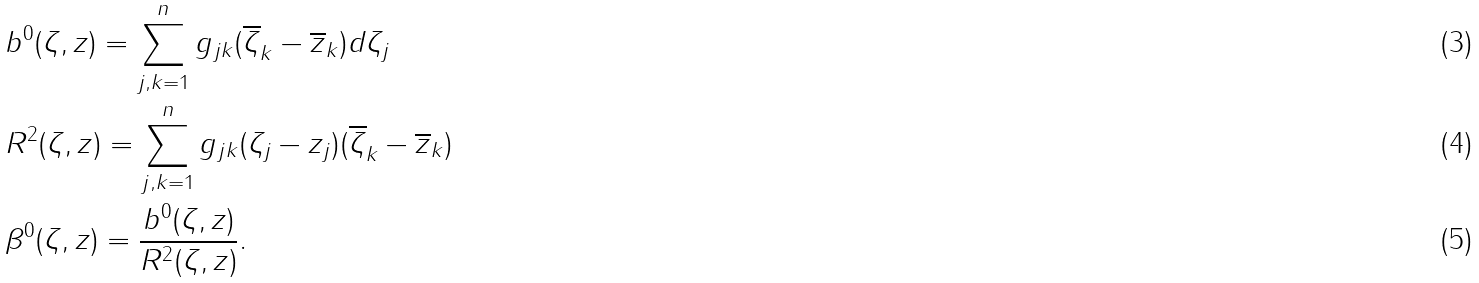Convert formula to latex. <formula><loc_0><loc_0><loc_500><loc_500>& b ^ { 0 } ( \zeta , z ) = \sum _ { j , k = 1 } ^ { n } g _ { j k } ( \overline { \zeta } _ { k } - \overline { z } _ { k } ) d \zeta _ { j } \\ & R ^ { 2 } ( \zeta , z ) = \sum _ { j , k = 1 } ^ { n } g _ { j k } ( \zeta _ { j } - z _ { j } ) ( \overline { \zeta } _ { k } - \overline { z } _ { k } ) \\ & \beta ^ { 0 } ( \zeta , z ) = \frac { b ^ { 0 } ( \zeta , z ) } { R ^ { 2 } ( \zeta , z ) } .</formula> 